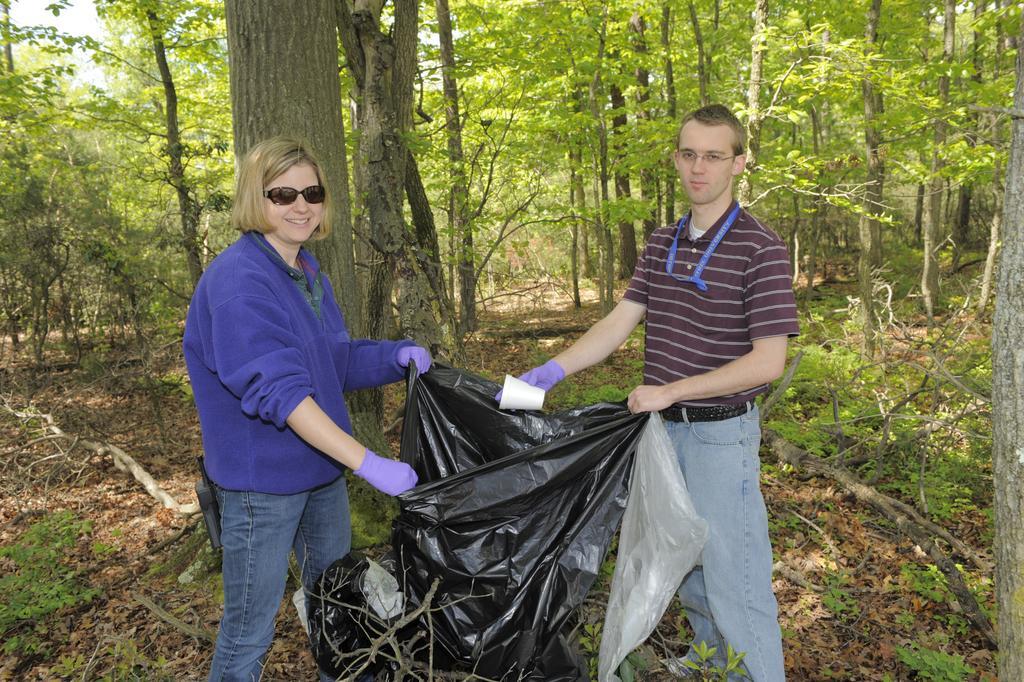Please provide a concise description of this image. In the picture we can see a man and a woman are standing in the forest area and holding a black color polythene cover and removing the dust from the path and putting in it and in the background we can see trees. 